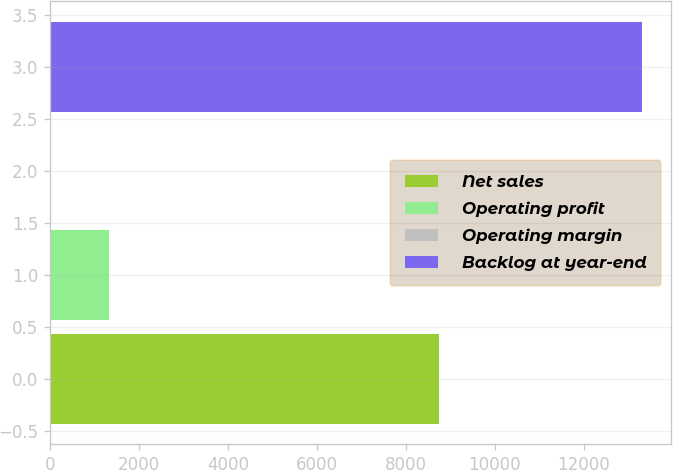Convert chart to OTSL. <chart><loc_0><loc_0><loc_500><loc_500><bar_chart><fcel>Net sales<fcel>Operating profit<fcel>Operating margin<fcel>Backlog at year-end<nl><fcel>8732<fcel>1339.63<fcel>10.7<fcel>13300<nl></chart> 